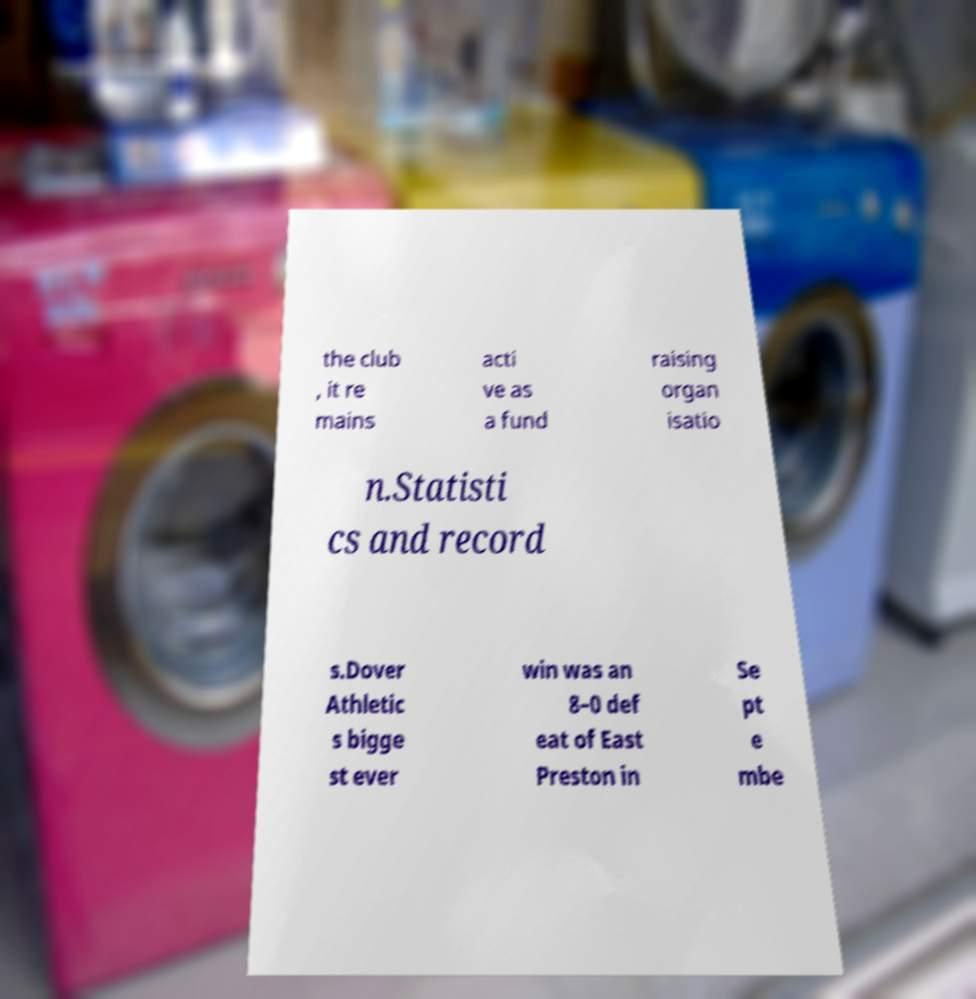Please identify and transcribe the text found in this image. the club , it re mains acti ve as a fund raising organ isatio n.Statisti cs and record s.Dover Athletic s bigge st ever win was an 8–0 def eat of East Preston in Se pt e mbe 